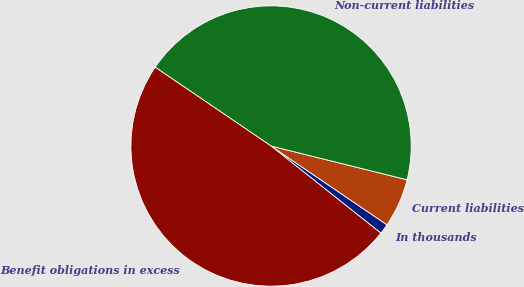Convert chart. <chart><loc_0><loc_0><loc_500><loc_500><pie_chart><fcel>In thousands<fcel>Current liabilities<fcel>Non-current liabilities<fcel>Benefit obligations in excess<nl><fcel>1.17%<fcel>5.63%<fcel>44.37%<fcel>48.83%<nl></chart> 